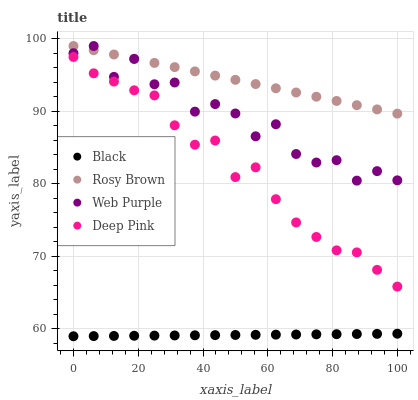Does Black have the minimum area under the curve?
Answer yes or no. Yes. Does Rosy Brown have the maximum area under the curve?
Answer yes or no. Yes. Does Rosy Brown have the minimum area under the curve?
Answer yes or no. No. Does Black have the maximum area under the curve?
Answer yes or no. No. Is Black the smoothest?
Answer yes or no. Yes. Is Web Purple the roughest?
Answer yes or no. Yes. Is Rosy Brown the smoothest?
Answer yes or no. No. Is Rosy Brown the roughest?
Answer yes or no. No. Does Black have the lowest value?
Answer yes or no. Yes. Does Rosy Brown have the lowest value?
Answer yes or no. No. Does Rosy Brown have the highest value?
Answer yes or no. Yes. Does Black have the highest value?
Answer yes or no. No. Is Deep Pink less than Rosy Brown?
Answer yes or no. Yes. Is Rosy Brown greater than Black?
Answer yes or no. Yes. Does Rosy Brown intersect Web Purple?
Answer yes or no. Yes. Is Rosy Brown less than Web Purple?
Answer yes or no. No. Is Rosy Brown greater than Web Purple?
Answer yes or no. No. Does Deep Pink intersect Rosy Brown?
Answer yes or no. No. 